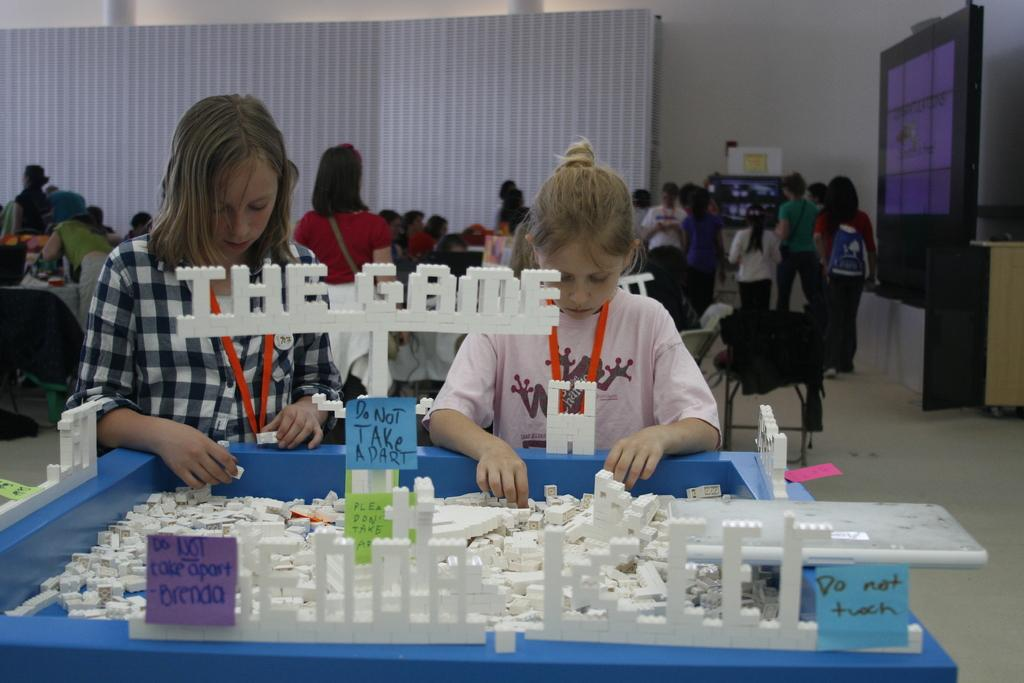How many people are in the image? There are two girls in the image. What are the girls doing in the image? The girls are trying to fix something. What type of objects are they fixing? The objects being fixed are ID cards. What color are the ID cards? The ID cards are orange in color. What type of noise can be heard coming from the frogs in the image? There are no frogs present in the image, so it is not possible to determine what noise they might be making. 